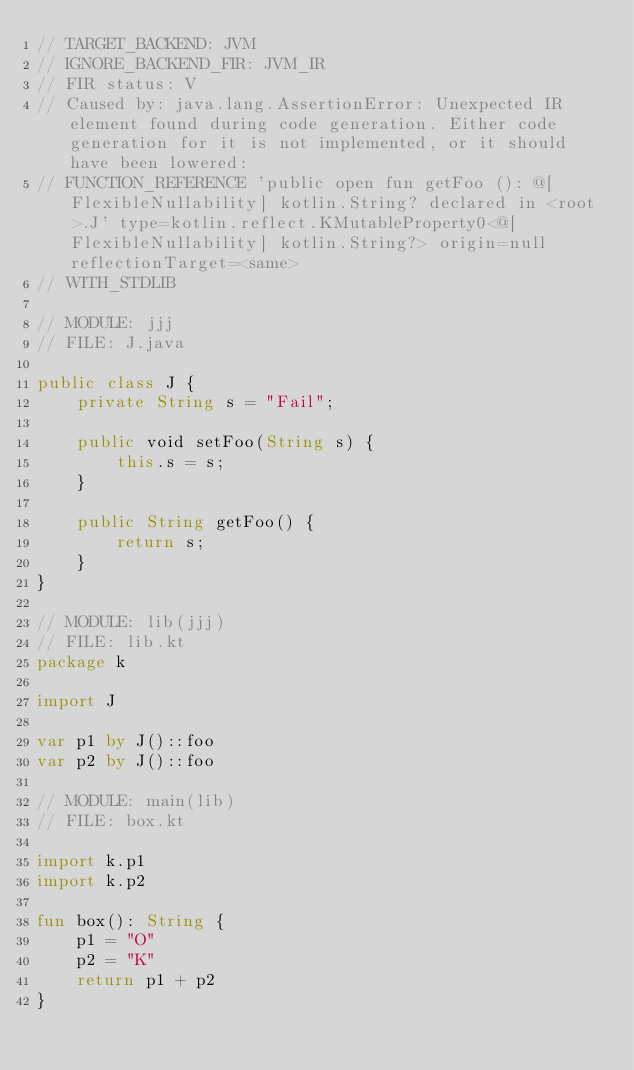<code> <loc_0><loc_0><loc_500><loc_500><_Kotlin_>// TARGET_BACKEND: JVM
// IGNORE_BACKEND_FIR: JVM_IR
// FIR status: V
// Caused by: java.lang.AssertionError: Unexpected IR element found during code generation. Either code generation for it is not implemented, or it should have been lowered:
// FUNCTION_REFERENCE 'public open fun getFoo (): @[FlexibleNullability] kotlin.String? declared in <root>.J' type=kotlin.reflect.KMutableProperty0<@[FlexibleNullability] kotlin.String?> origin=null reflectionTarget=<same>
// WITH_STDLIB

// MODULE: jjj
// FILE: J.java

public class J {
    private String s = "Fail";

    public void setFoo(String s) {
        this.s = s;
    }

    public String getFoo() {
        return s;
    }
}

// MODULE: lib(jjj)
// FILE: lib.kt
package k

import J

var p1 by J()::foo
var p2 by J()::foo

// MODULE: main(lib)
// FILE: box.kt

import k.p1
import k.p2

fun box(): String {
    p1 = "O"
    p2 = "K"
    return p1 + p2
}

</code> 